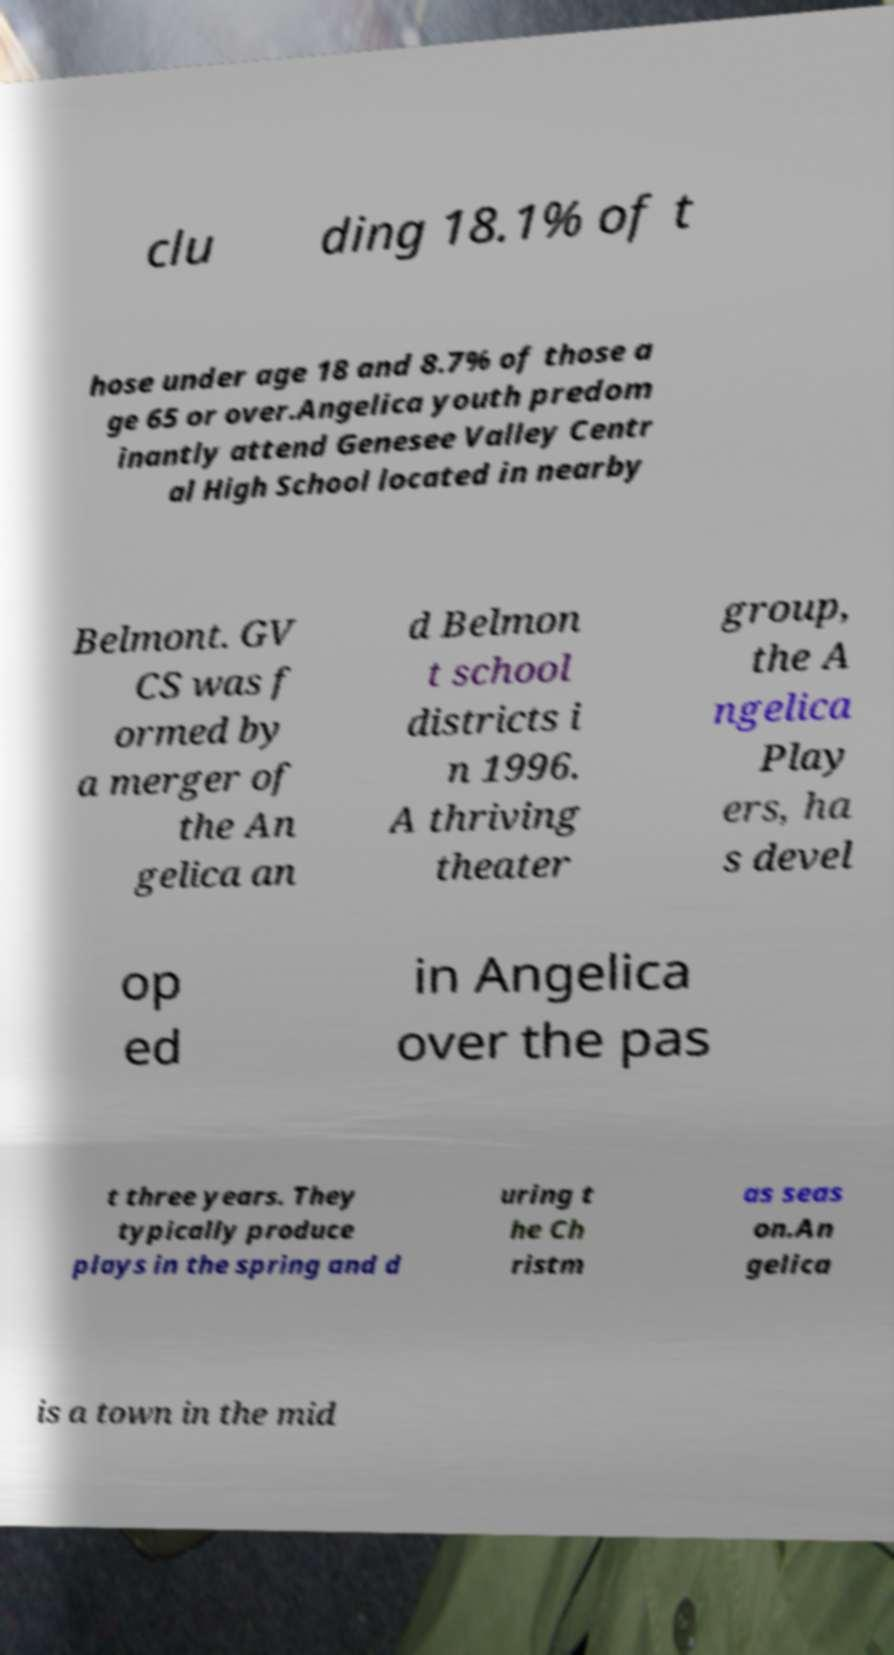Can you accurately transcribe the text from the provided image for me? clu ding 18.1% of t hose under age 18 and 8.7% of those a ge 65 or over.Angelica youth predom inantly attend Genesee Valley Centr al High School located in nearby Belmont. GV CS was f ormed by a merger of the An gelica an d Belmon t school districts i n 1996. A thriving theater group, the A ngelica Play ers, ha s devel op ed in Angelica over the pas t three years. They typically produce plays in the spring and d uring t he Ch ristm as seas on.An gelica is a town in the mid 